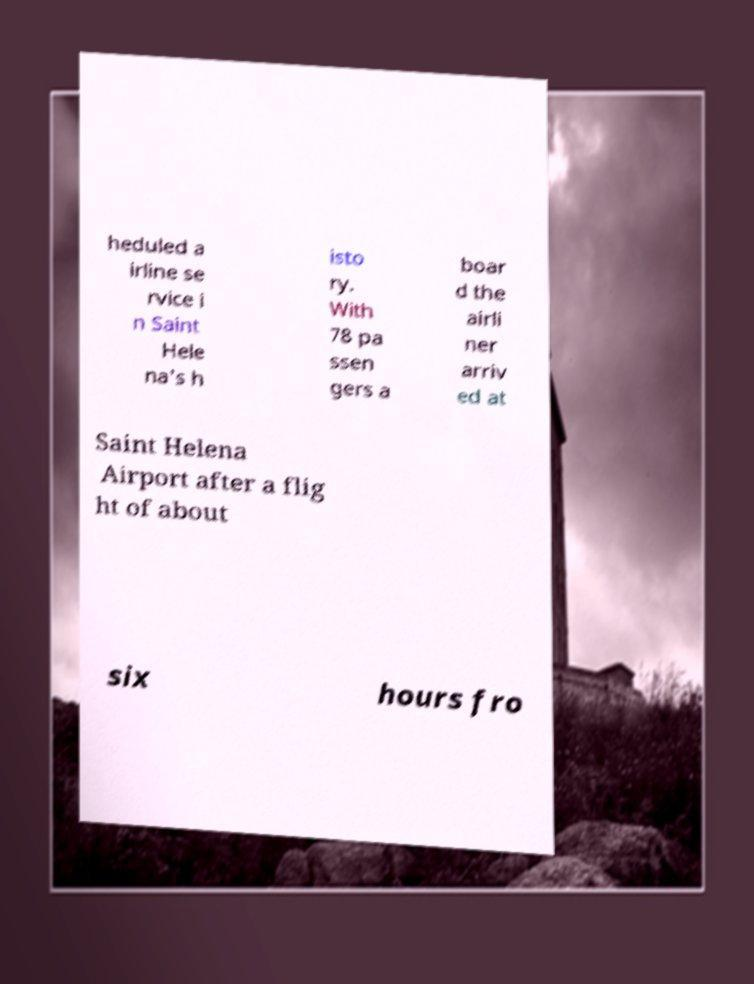Please identify and transcribe the text found in this image. heduled a irline se rvice i n Saint Hele na's h isto ry. With 78 pa ssen gers a boar d the airli ner arriv ed at Saint Helena Airport after a flig ht of about six hours fro 